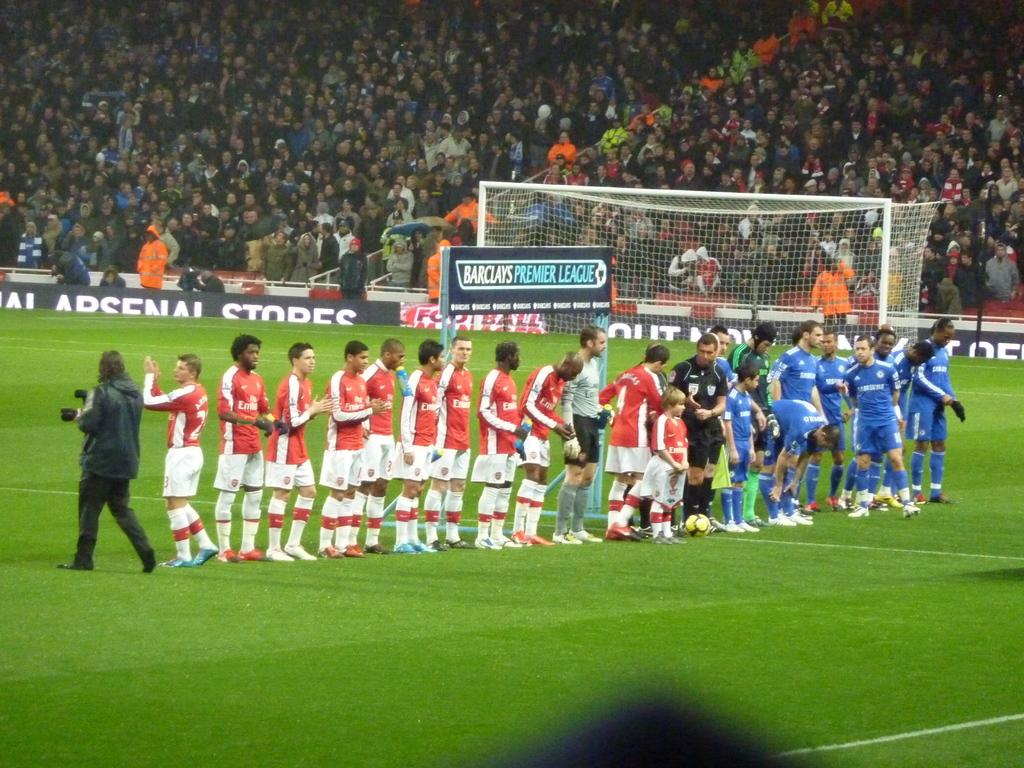<image>
Write a terse but informative summary of the picture. Barclays Premier League soccer players are lined up on a field. 